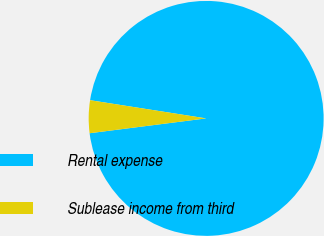Convert chart to OTSL. <chart><loc_0><loc_0><loc_500><loc_500><pie_chart><fcel>Rental expense<fcel>Sublease income from third<nl><fcel>95.51%<fcel>4.49%<nl></chart> 